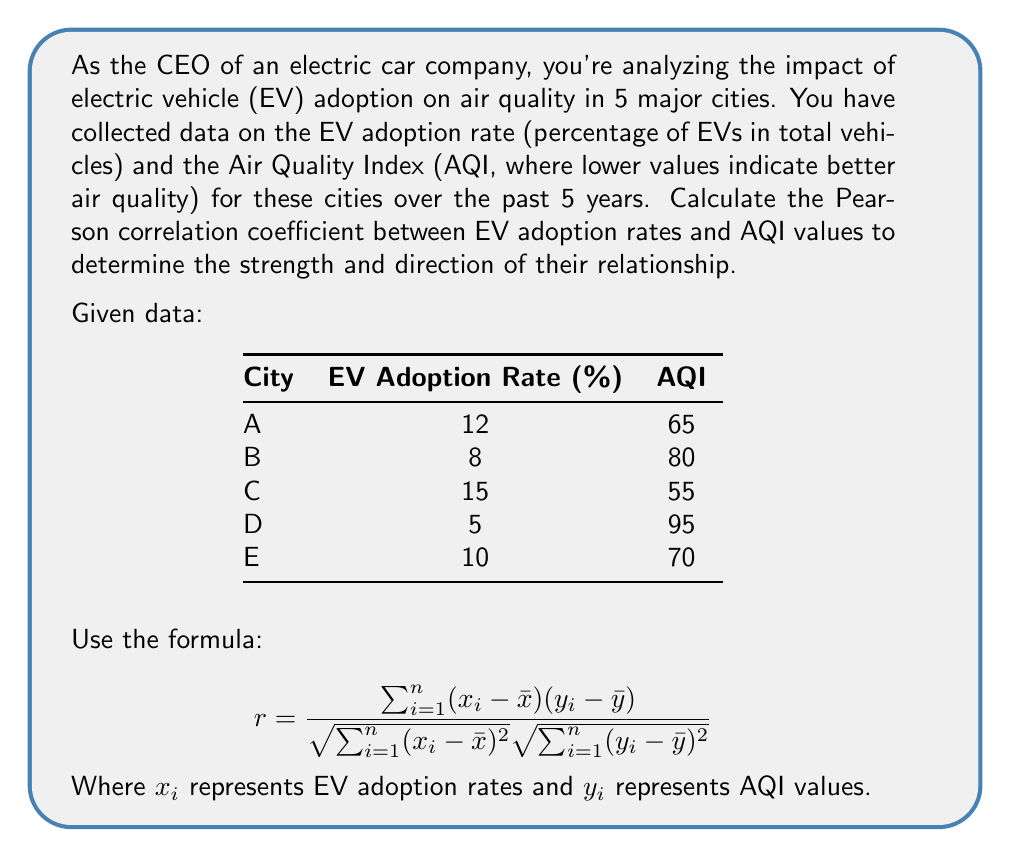Give your solution to this math problem. To calculate the Pearson correlation coefficient, we'll follow these steps:

1. Calculate the means of EV adoption rates ($\bar{x}$) and AQI values ($\bar{y}$):
   $\bar{x} = (12 + 8 + 15 + 5 + 10) / 5 = 10$
   $\bar{y} = (65 + 80 + 55 + 95 + 70) / 5 = 73$

2. Calculate $(x_i - \bar{x})$ and $(y_i - \bar{y})$ for each city:
   City A: (12 - 10) = 2,    (65 - 73) = -8
   City B: (8 - 10) = -2,    (80 - 73) = 7
   City C: (15 - 10) = 5,    (55 - 73) = -18
   City D: (5 - 10) = -5,    (95 - 73) = 22
   City E: (10 - 10) = 0,    (70 - 73) = -3

3. Calculate the products $(x_i - \bar{x})(y_i - \bar{y})$:
   City A: 2 * (-8) = -16
   City B: (-2) * 7 = -14
   City C: 5 * (-18) = -90
   City D: (-5) * 22 = -110
   City E: 0 * (-3) = 0

4. Sum the products:
   $\sum_{i=1}^{n} (x_i - \bar{x})(y_i - \bar{y}) = -16 - 14 - 90 - 110 + 0 = -230$

5. Calculate $\sum_{i=1}^{n} (x_i - \bar{x})^2$:
   $2^2 + (-2)^2 + 5^2 + (-5)^2 + 0^2 = 4 + 4 + 25 + 25 + 0 = 58$

6. Calculate $\sum_{i=1}^{n} (y_i - \bar{y})^2$:
   $(-8)^2 + 7^2 + (-18)^2 + 22^2 + (-3)^2 = 64 + 49 + 324 + 484 + 9 = 930$

7. Apply the formula:

$$ r = \frac{-230}{\sqrt{58} \sqrt{930}} = \frac{-230}{\sqrt{53940}} = \frac{-230}{232.25} \approx -0.9904 $$
Answer: $r \approx -0.9904$ 